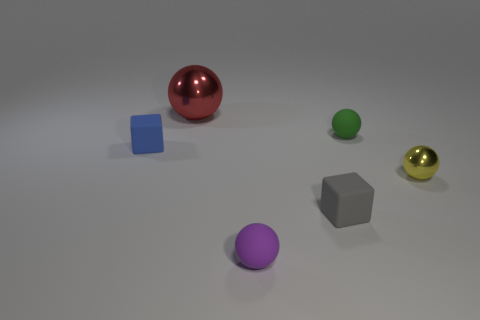There is a small yellow thing that is the same shape as the big shiny object; what is it made of?
Give a very brief answer. Metal. Are there more small spheres to the right of the small green thing than big objects to the right of the small purple object?
Your answer should be compact. Yes. Is there any other thing that has the same size as the red sphere?
Your answer should be compact. No. What number of balls are either green objects or matte things?
Offer a very short reply. 2. What number of things are either small green balls that are on the right side of the gray cube or large brown matte balls?
Provide a succinct answer. 1. What is the shape of the small object that is to the left of the metallic ball that is to the left of the tiny matte sphere that is on the left side of the tiny gray object?
Ensure brevity in your answer.  Cube. What number of matte objects have the same shape as the big metallic thing?
Your answer should be compact. 2. Is the material of the big ball the same as the gray block?
Your answer should be compact. No. There is a small sphere in front of the small thing that is on the right side of the green matte object; what number of big shiny objects are in front of it?
Your answer should be very brief. 0. Is there a tiny blue thing made of the same material as the gray thing?
Your response must be concise. Yes. 